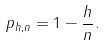Convert formula to latex. <formula><loc_0><loc_0><loc_500><loc_500>p _ { h , n } = 1 - \frac { h } { n } .</formula> 